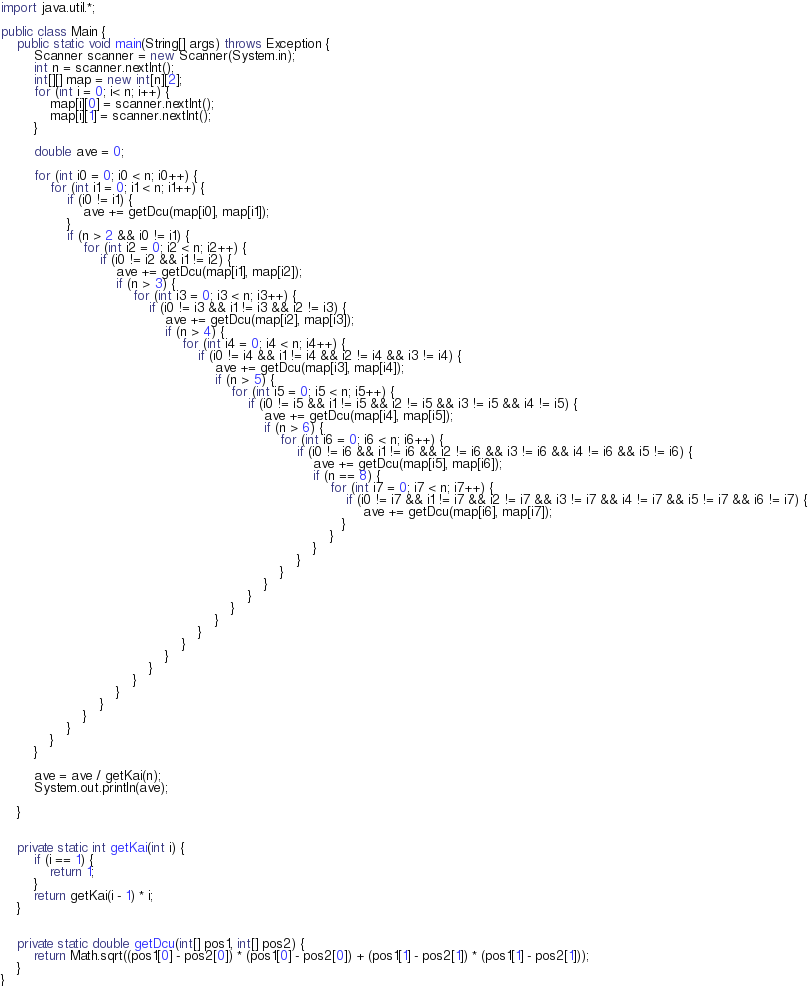Convert code to text. <code><loc_0><loc_0><loc_500><loc_500><_Java_>import java.util.*;

public class Main {
    public static void main(String[] args) throws Exception {
        Scanner scanner = new Scanner(System.in);
        int n = scanner.nextInt();
        int[][] map = new int[n][2];
        for (int i = 0; i< n; i++) {
            map[i][0] = scanner.nextInt();
            map[i][1] = scanner.nextInt();
        }
        
        double ave = 0;
        
        for (int i0 = 0; i0 < n; i0++) {
            for (int i1 = 0; i1 < n; i1++) {
                if (i0 != i1) {
                    ave += getDcu(map[i0], map[i1]);
                }
                if (n > 2 && i0 != i1) {
                    for (int i2 = 0; i2 < n; i2++) {
                        if (i0 != i2 && i1 != i2) {
                            ave += getDcu(map[i1], map[i2]);
                            if (n > 3) {
                                for (int i3 = 0; i3 < n; i3++) {
                                    if (i0 != i3 && i1 != i3 && i2 != i3) {
                                        ave += getDcu(map[i2], map[i3]);
                                        if (n > 4) {
                                            for (int i4 = 0; i4 < n; i4++) {
                                                if (i0 != i4 && i1 != i4 && i2 != i4 && i3 != i4) {
                                                    ave += getDcu(map[i3], map[i4]);
                                                    if (n > 5) {
                                                        for (int i5 = 0; i5 < n; i5++) {
                                                            if (i0 != i5 && i1 != i5 && i2 != i5 && i3 != i5 && i4 != i5) {
                                                                ave += getDcu(map[i4], map[i5]);
                                                                if (n > 6) {
                                                                    for (int i6 = 0; i6 < n; i6++) {
                                                                        if (i0 != i6 && i1 != i6 && i2 != i6 && i3 != i6 && i4 != i6 && i5 != i6) {
                                                                            ave += getDcu(map[i5], map[i6]);
                                                                            if (n == 8) {
                                                                                for (int i7 = 0; i7 < n; i7++) {
                                                                                    if (i0 != i7 && i1 != i7 && i2 != i7 && i3 != i7 && i4 != i7 && i5 != i7 && i6 != i7) {
                                                                                        ave += getDcu(map[i6], map[i7]);
                                                                                   }
                                                                                }
                                                                            }
                                                                        }
                                                                    }
                                                                }
                                                            }
                                                        }
                                                    }
                                                }
                                            }
                                        }
                                    }
                                }
                            }
                        }
                    }
                }
            }
        }
        
        ave = ave / getKai(n);
        System.out.println(ave);
        
    }
    
    
    private static int getKai(int i) {
        if (i == 1) {
            return 1;
        }
        return getKai(i - 1) * i;
    }
    
    
    private static double getDcu(int[] pos1, int[] pos2) {
        return Math.sqrt((pos1[0] - pos2[0]) * (pos1[0] - pos2[0]) + (pos1[1] - pos2[1]) * (pos1[1] - pos2[1]));
    }
}
</code> 